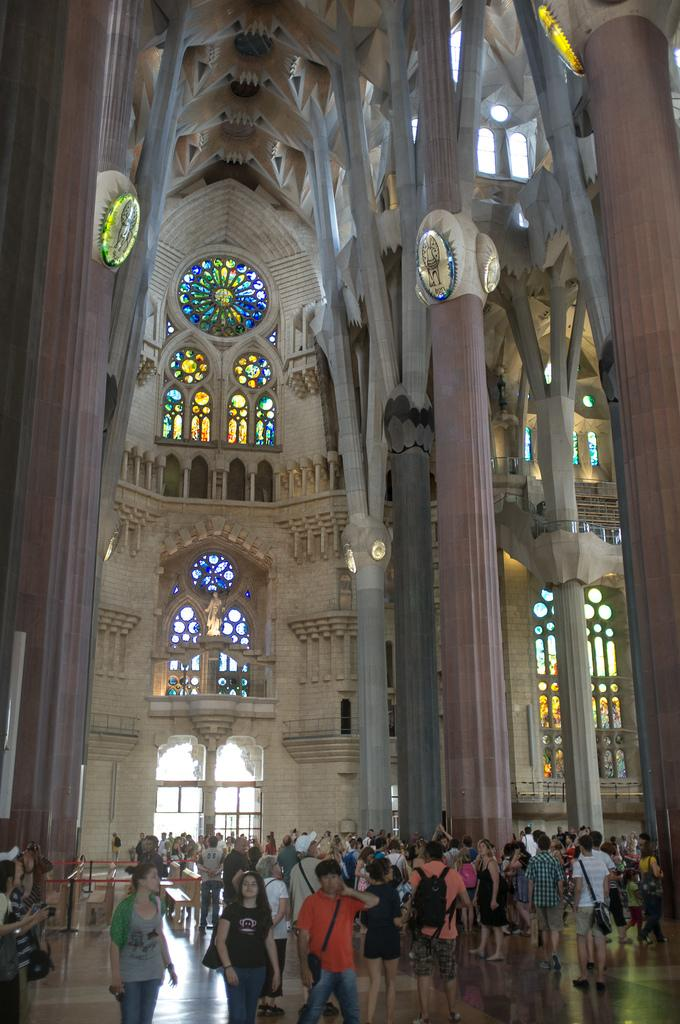What architectural features can be seen in the image? There are pillars in the image. What is happening at the bottom of the image? There is a crowd at the bottom of the image. What type of insect can be seen crawling on the sidewalk in the image? There is no sidewalk or insect present in the image. 